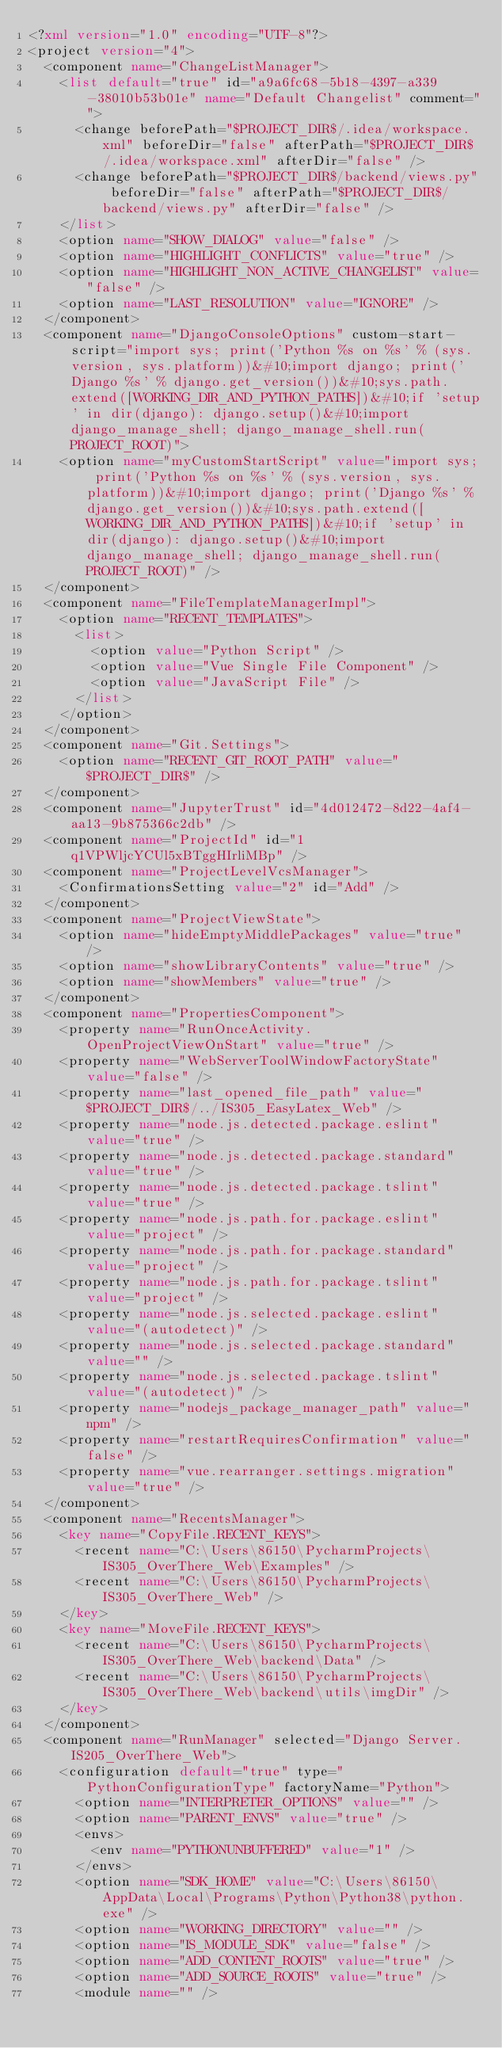Convert code to text. <code><loc_0><loc_0><loc_500><loc_500><_XML_><?xml version="1.0" encoding="UTF-8"?>
<project version="4">
  <component name="ChangeListManager">
    <list default="true" id="a9a6fc68-5b18-4397-a339-38010b53b01e" name="Default Changelist" comment="">
      <change beforePath="$PROJECT_DIR$/.idea/workspace.xml" beforeDir="false" afterPath="$PROJECT_DIR$/.idea/workspace.xml" afterDir="false" />
      <change beforePath="$PROJECT_DIR$/backend/views.py" beforeDir="false" afterPath="$PROJECT_DIR$/backend/views.py" afterDir="false" />
    </list>
    <option name="SHOW_DIALOG" value="false" />
    <option name="HIGHLIGHT_CONFLICTS" value="true" />
    <option name="HIGHLIGHT_NON_ACTIVE_CHANGELIST" value="false" />
    <option name="LAST_RESOLUTION" value="IGNORE" />
  </component>
  <component name="DjangoConsoleOptions" custom-start-script="import sys; print('Python %s on %s' % (sys.version, sys.platform))&#10;import django; print('Django %s' % django.get_version())&#10;sys.path.extend([WORKING_DIR_AND_PYTHON_PATHS])&#10;if 'setup' in dir(django): django.setup()&#10;import django_manage_shell; django_manage_shell.run(PROJECT_ROOT)">
    <option name="myCustomStartScript" value="import sys; print('Python %s on %s' % (sys.version, sys.platform))&#10;import django; print('Django %s' % django.get_version())&#10;sys.path.extend([WORKING_DIR_AND_PYTHON_PATHS])&#10;if 'setup' in dir(django): django.setup()&#10;import django_manage_shell; django_manage_shell.run(PROJECT_ROOT)" />
  </component>
  <component name="FileTemplateManagerImpl">
    <option name="RECENT_TEMPLATES">
      <list>
        <option value="Python Script" />
        <option value="Vue Single File Component" />
        <option value="JavaScript File" />
      </list>
    </option>
  </component>
  <component name="Git.Settings">
    <option name="RECENT_GIT_ROOT_PATH" value="$PROJECT_DIR$" />
  </component>
  <component name="JupyterTrust" id="4d012472-8d22-4af4-aa13-9b875366c2db" />
  <component name="ProjectId" id="1q1VPWljcYCUl5xBTggHIrliMBp" />
  <component name="ProjectLevelVcsManager">
    <ConfirmationsSetting value="2" id="Add" />
  </component>
  <component name="ProjectViewState">
    <option name="hideEmptyMiddlePackages" value="true" />
    <option name="showLibraryContents" value="true" />
    <option name="showMembers" value="true" />
  </component>
  <component name="PropertiesComponent">
    <property name="RunOnceActivity.OpenProjectViewOnStart" value="true" />
    <property name="WebServerToolWindowFactoryState" value="false" />
    <property name="last_opened_file_path" value="$PROJECT_DIR$/../IS305_EasyLatex_Web" />
    <property name="node.js.detected.package.eslint" value="true" />
    <property name="node.js.detected.package.standard" value="true" />
    <property name="node.js.detected.package.tslint" value="true" />
    <property name="node.js.path.for.package.eslint" value="project" />
    <property name="node.js.path.for.package.standard" value="project" />
    <property name="node.js.path.for.package.tslint" value="project" />
    <property name="node.js.selected.package.eslint" value="(autodetect)" />
    <property name="node.js.selected.package.standard" value="" />
    <property name="node.js.selected.package.tslint" value="(autodetect)" />
    <property name="nodejs_package_manager_path" value="npm" />
    <property name="restartRequiresConfirmation" value="false" />
    <property name="vue.rearranger.settings.migration" value="true" />
  </component>
  <component name="RecentsManager">
    <key name="CopyFile.RECENT_KEYS">
      <recent name="C:\Users\86150\PycharmProjects\IS305_OverThere_Web\Examples" />
      <recent name="C:\Users\86150\PycharmProjects\IS305_OverThere_Web" />
    </key>
    <key name="MoveFile.RECENT_KEYS">
      <recent name="C:\Users\86150\PycharmProjects\IS305_OverThere_Web\backend\Data" />
      <recent name="C:\Users\86150\PycharmProjects\IS305_OverThere_Web\backend\utils\imgDir" />
    </key>
  </component>
  <component name="RunManager" selected="Django Server.IS205_OverThere_Web">
    <configuration default="true" type="PythonConfigurationType" factoryName="Python">
      <option name="INTERPRETER_OPTIONS" value="" />
      <option name="PARENT_ENVS" value="true" />
      <envs>
        <env name="PYTHONUNBUFFERED" value="1" />
      </envs>
      <option name="SDK_HOME" value="C:\Users\86150\AppData\Local\Programs\Python\Python38\python.exe" />
      <option name="WORKING_DIRECTORY" value="" />
      <option name="IS_MODULE_SDK" value="false" />
      <option name="ADD_CONTENT_ROOTS" value="true" />
      <option name="ADD_SOURCE_ROOTS" value="true" />
      <module name="" /></code> 